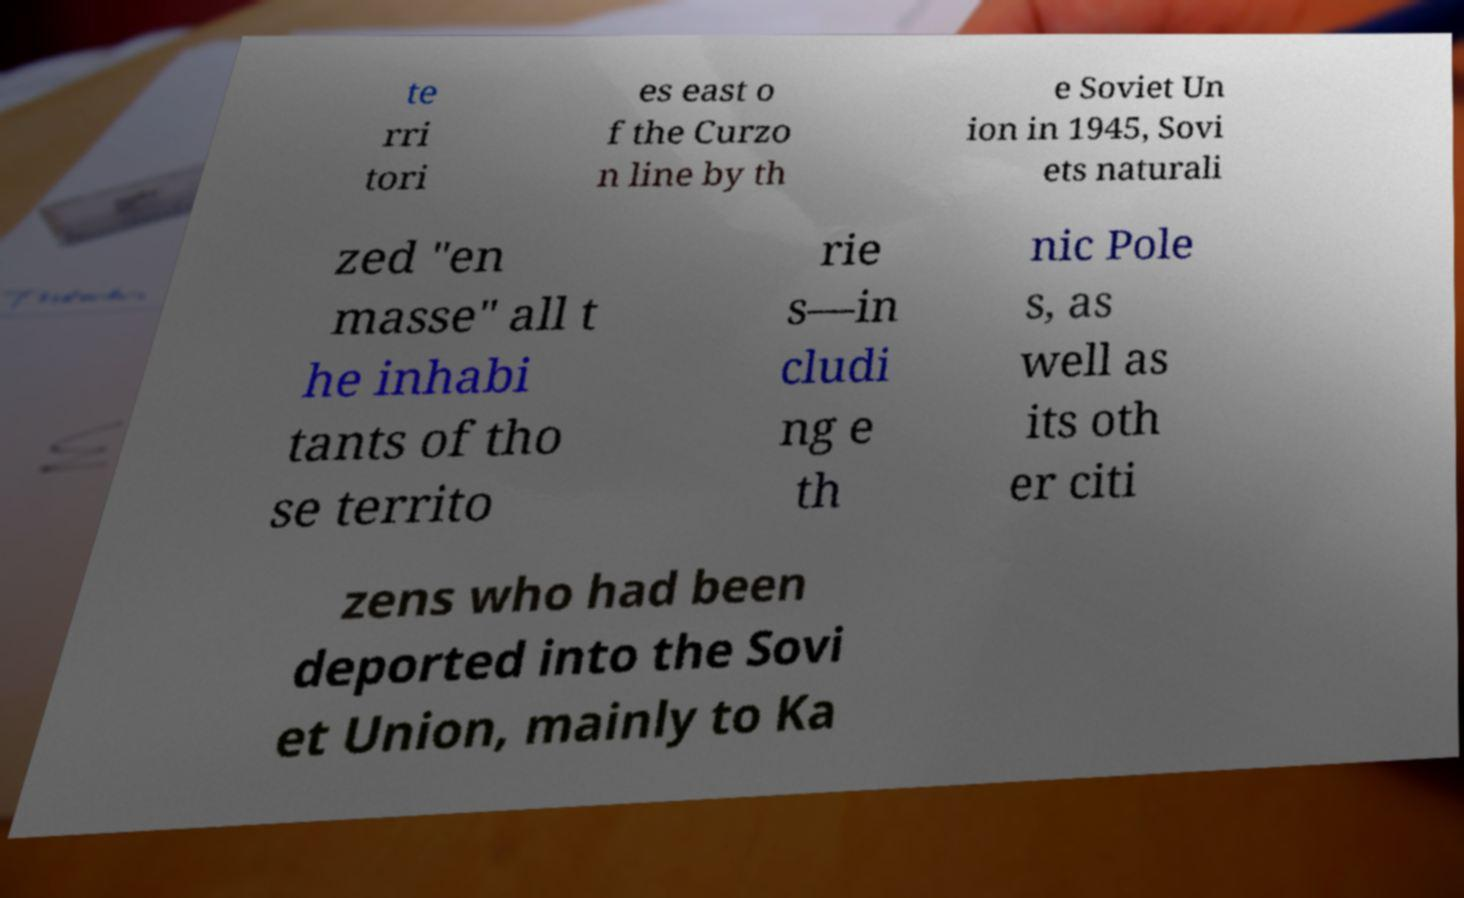Could you assist in decoding the text presented in this image and type it out clearly? te rri tori es east o f the Curzo n line by th e Soviet Un ion in 1945, Sovi ets naturali zed "en masse" all t he inhabi tants of tho se territo rie s—in cludi ng e th nic Pole s, as well as its oth er citi zens who had been deported into the Sovi et Union, mainly to Ka 